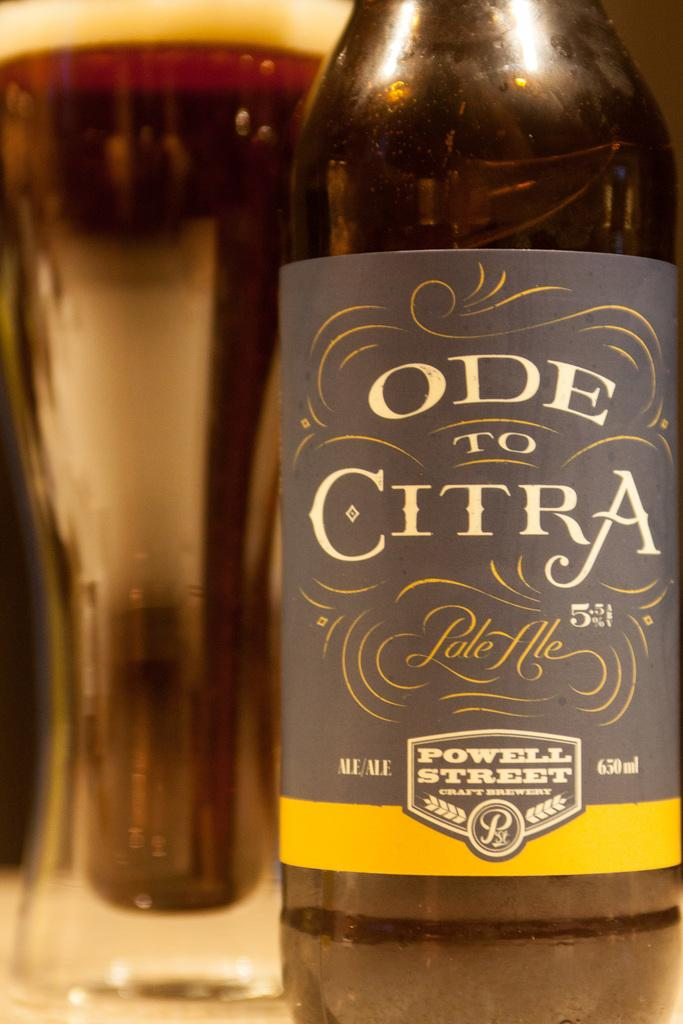<image>
Render a clear and concise summary of the photo. A bottle of Ode to Citra pale ale has a gray and yellow label. 